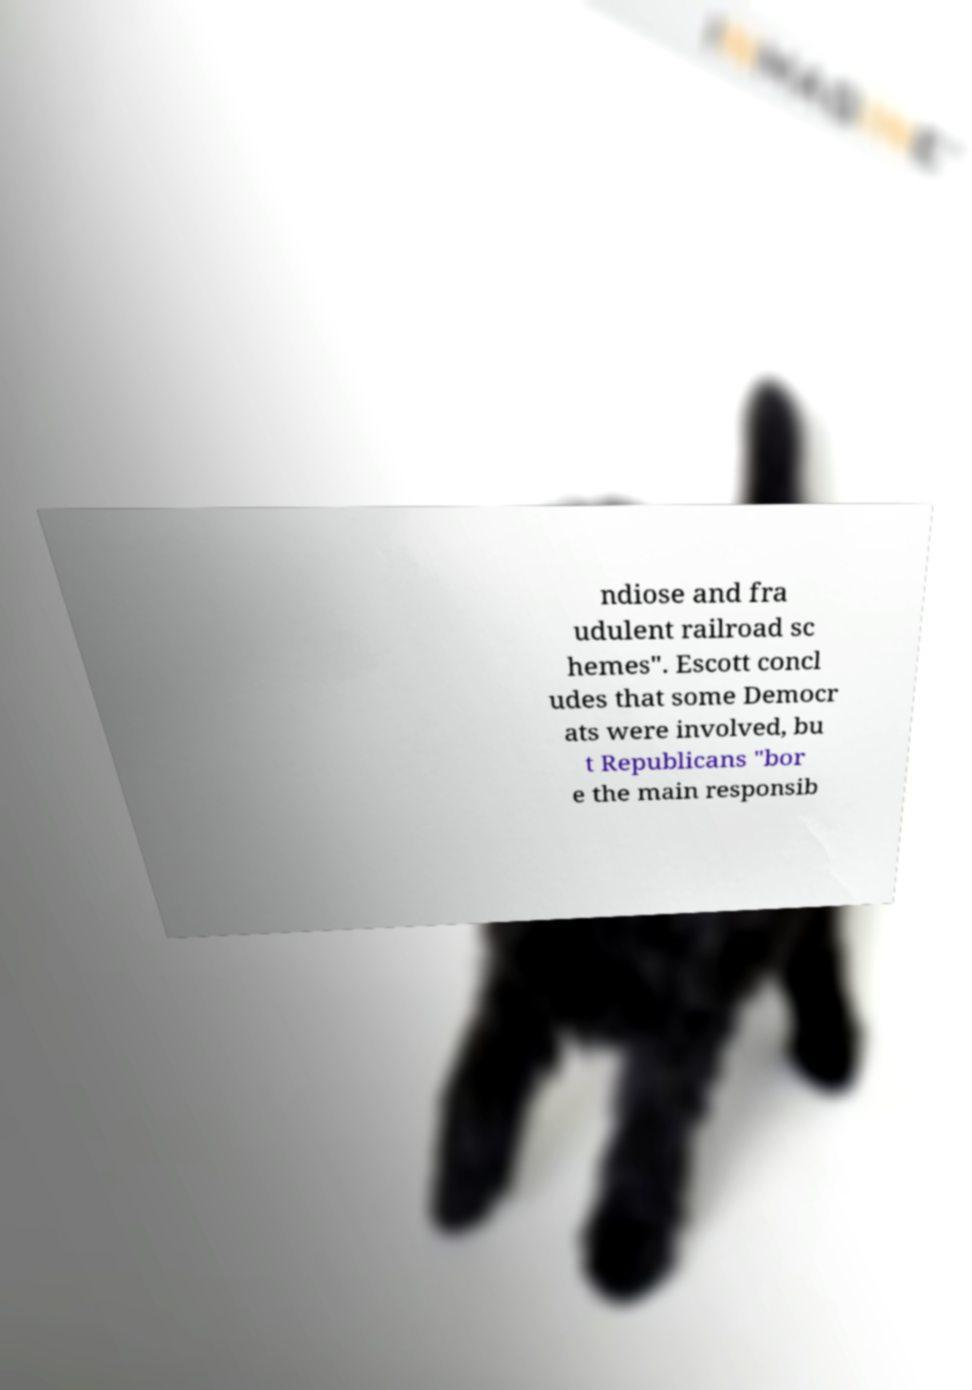Please identify and transcribe the text found in this image. ndiose and fra udulent railroad sc hemes". Escott concl udes that some Democr ats were involved, bu t Republicans "bor e the main responsib 